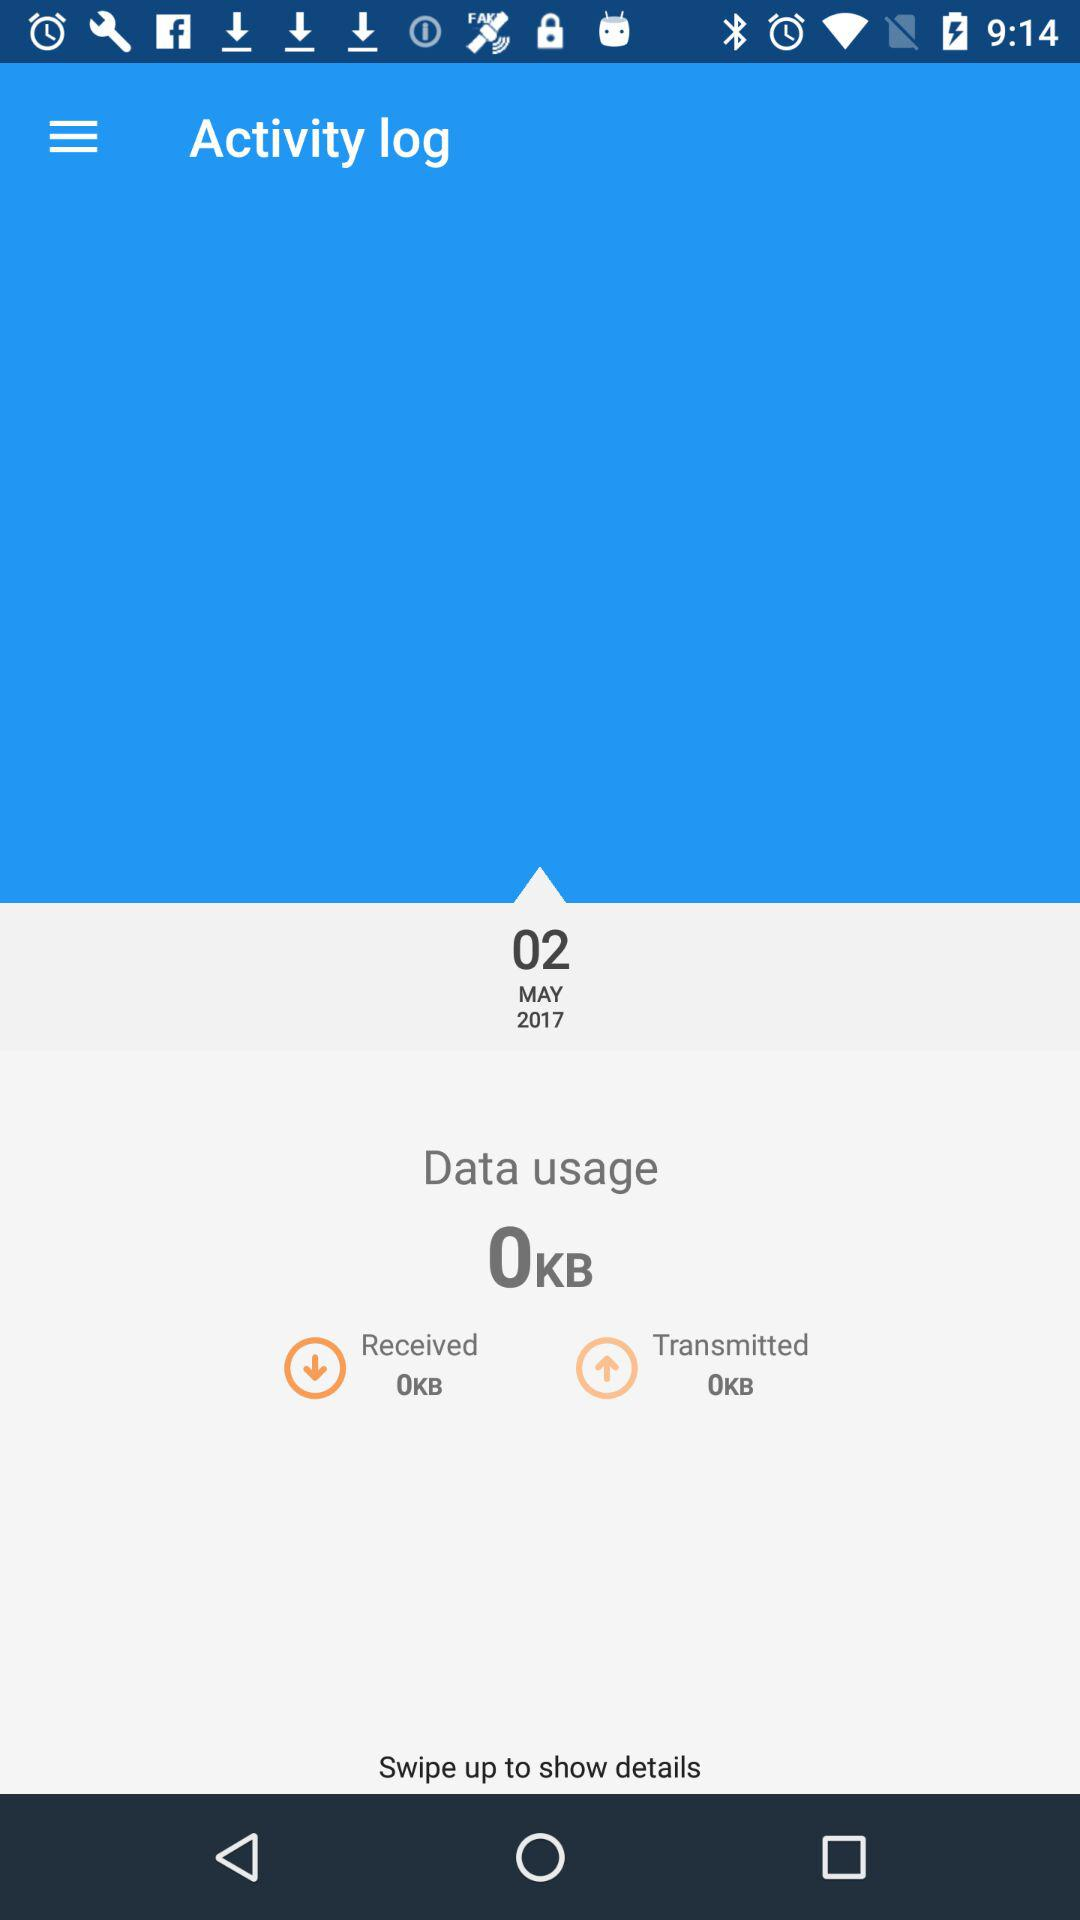How much data usage has been done? The data usage is 0KB. 